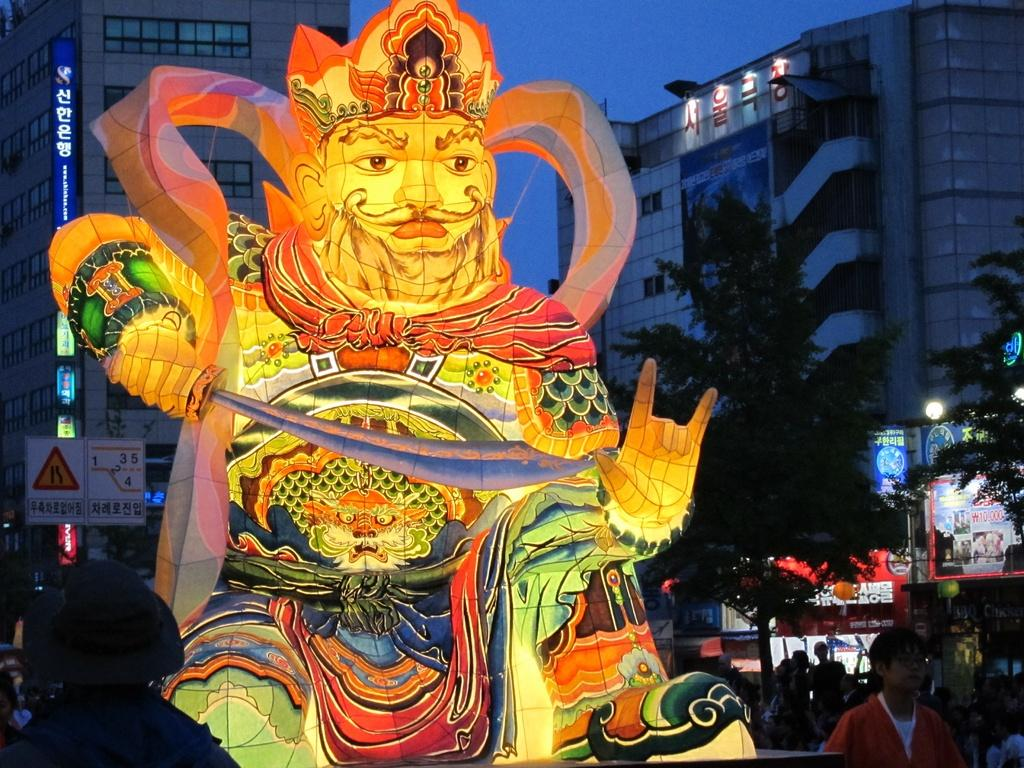What is the main subject in the center of the image? There is a statue in the center of the image. What can be seen at the bottom of the image? There are persons at the bottom of the image. What is visible in the background of the image? Buildings, persons, vehicles, trees, and the sky are visible in the background of the image. What type of fog can be seen surrounding the statue in the image? There is no fog present in the image; the statue and its surroundings are clearly visible. 